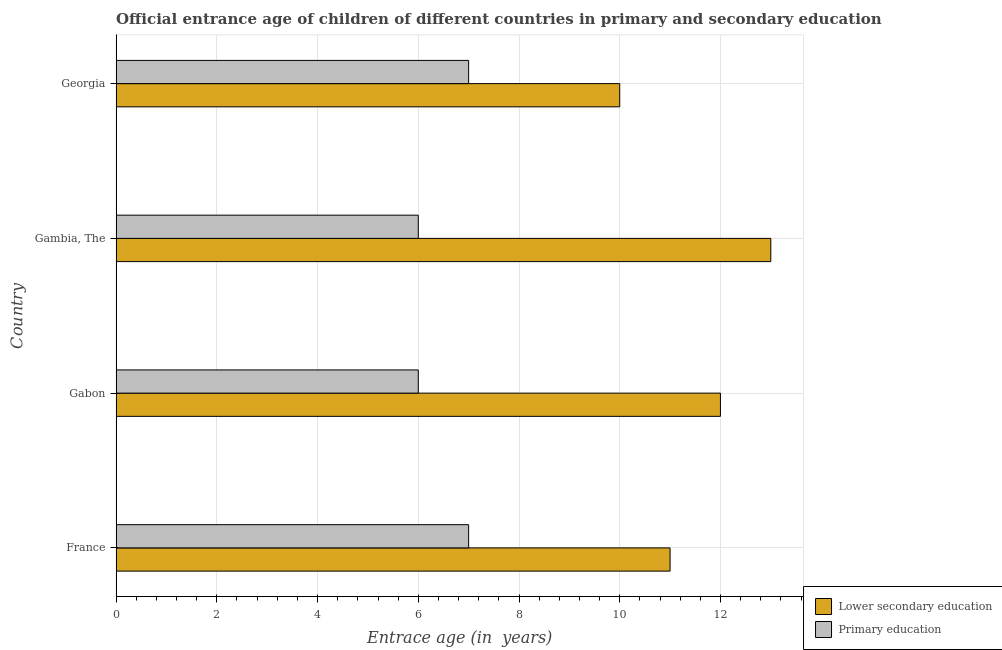Are the number of bars per tick equal to the number of legend labels?
Offer a terse response. Yes. Are the number of bars on each tick of the Y-axis equal?
Offer a very short reply. Yes. How many bars are there on the 3rd tick from the top?
Your answer should be compact. 2. What is the label of the 3rd group of bars from the top?
Your answer should be very brief. Gabon. What is the entrance age of children in lower secondary education in Gambia, The?
Give a very brief answer. 13. Across all countries, what is the maximum entrance age of chiildren in primary education?
Your response must be concise. 7. Across all countries, what is the minimum entrance age of children in lower secondary education?
Your answer should be very brief. 10. In which country was the entrance age of chiildren in primary education maximum?
Ensure brevity in your answer.  France. In which country was the entrance age of chiildren in primary education minimum?
Offer a terse response. Gabon. What is the total entrance age of chiildren in primary education in the graph?
Ensure brevity in your answer.  26. What is the difference between the entrance age of children in lower secondary education in Gambia, The and that in Georgia?
Ensure brevity in your answer.  3. What is the difference between the entrance age of chiildren in primary education in Gambia, The and the entrance age of children in lower secondary education in France?
Your response must be concise. -5. What is the difference between the entrance age of chiildren in primary education and entrance age of children in lower secondary education in Gabon?
Provide a succinct answer. -6. In how many countries, is the entrance age of chiildren in primary education greater than 10 years?
Offer a terse response. 0. What is the ratio of the entrance age of chiildren in primary education in Gabon to that in Georgia?
Your answer should be very brief. 0.86. What is the difference between the highest and the lowest entrance age of children in lower secondary education?
Offer a very short reply. 3. In how many countries, is the entrance age of chiildren in primary education greater than the average entrance age of chiildren in primary education taken over all countries?
Keep it short and to the point. 2. Are all the bars in the graph horizontal?
Your answer should be compact. Yes. Are the values on the major ticks of X-axis written in scientific E-notation?
Ensure brevity in your answer.  No. Does the graph contain grids?
Provide a succinct answer. Yes. How many legend labels are there?
Ensure brevity in your answer.  2. What is the title of the graph?
Provide a succinct answer. Official entrance age of children of different countries in primary and secondary education. Does "Young" appear as one of the legend labels in the graph?
Provide a succinct answer. No. What is the label or title of the X-axis?
Give a very brief answer. Entrace age (in  years). What is the label or title of the Y-axis?
Your response must be concise. Country. What is the Entrace age (in  years) in Lower secondary education in Gabon?
Give a very brief answer. 12. What is the Entrace age (in  years) of Primary education in Gambia, The?
Give a very brief answer. 6. Across all countries, what is the maximum Entrace age (in  years) of Primary education?
Provide a short and direct response. 7. Across all countries, what is the minimum Entrace age (in  years) of Lower secondary education?
Offer a very short reply. 10. What is the difference between the Entrace age (in  years) of Lower secondary education in France and that in Gambia, The?
Provide a short and direct response. -2. What is the difference between the Entrace age (in  years) of Lower secondary education in Gabon and that in Gambia, The?
Give a very brief answer. -1. What is the difference between the Entrace age (in  years) of Primary education in Gabon and that in Gambia, The?
Offer a terse response. 0. What is the difference between the Entrace age (in  years) in Lower secondary education in Gabon and that in Georgia?
Offer a terse response. 2. What is the difference between the Entrace age (in  years) in Primary education in Gabon and that in Georgia?
Ensure brevity in your answer.  -1. What is the difference between the Entrace age (in  years) in Lower secondary education in Gambia, The and that in Georgia?
Keep it short and to the point. 3. What is the difference between the Entrace age (in  years) of Lower secondary education in France and the Entrace age (in  years) of Primary education in Georgia?
Keep it short and to the point. 4. What is the difference between the Entrace age (in  years) of Lower secondary education in Gabon and the Entrace age (in  years) of Primary education in Gambia, The?
Provide a succinct answer. 6. What is the difference between the Entrace age (in  years) of Lower secondary education in Gambia, The and the Entrace age (in  years) of Primary education in Georgia?
Keep it short and to the point. 6. What is the average Entrace age (in  years) in Lower secondary education per country?
Provide a succinct answer. 11.5. What is the difference between the Entrace age (in  years) in Lower secondary education and Entrace age (in  years) in Primary education in Gambia, The?
Give a very brief answer. 7. What is the ratio of the Entrace age (in  years) in Lower secondary education in France to that in Gambia, The?
Provide a short and direct response. 0.85. What is the ratio of the Entrace age (in  years) of Primary education in France to that in Georgia?
Offer a very short reply. 1. What is the ratio of the Entrace age (in  years) in Lower secondary education in Gabon to that in Gambia, The?
Your answer should be compact. 0.92. What is the ratio of the Entrace age (in  years) of Primary education in Gabon to that in Gambia, The?
Provide a short and direct response. 1. What is the ratio of the Entrace age (in  years) of Lower secondary education in Gambia, The to that in Georgia?
Your response must be concise. 1.3. What is the difference between the highest and the lowest Entrace age (in  years) in Lower secondary education?
Offer a very short reply. 3. 